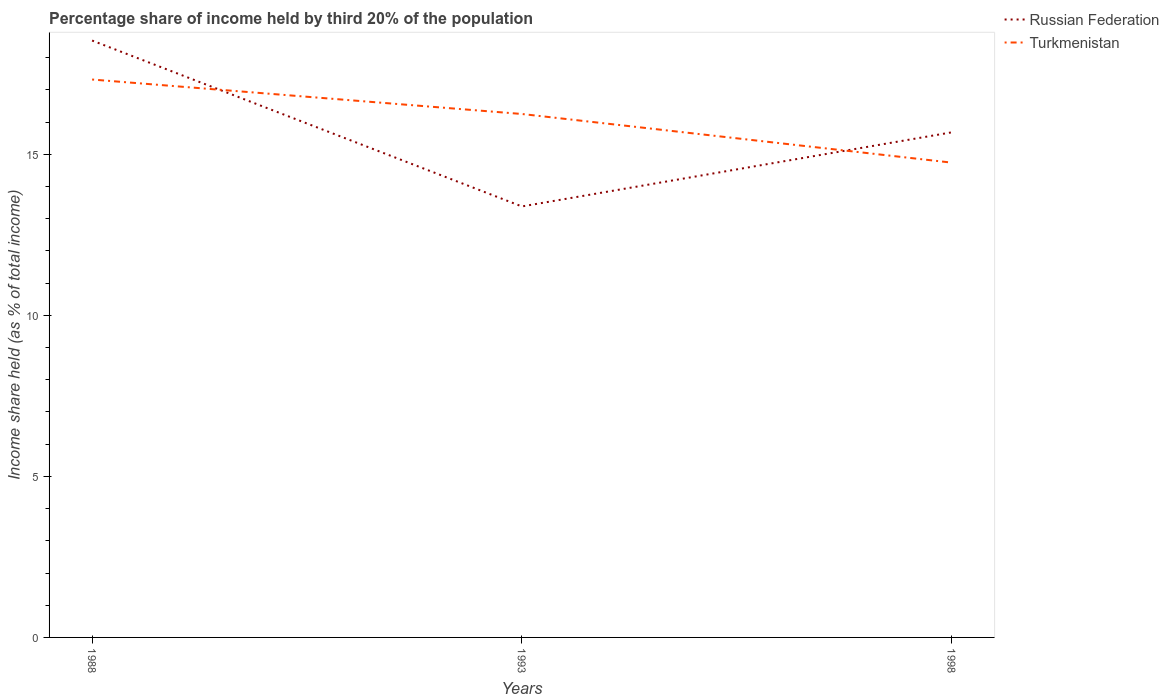How many different coloured lines are there?
Give a very brief answer. 2. Does the line corresponding to Russian Federation intersect with the line corresponding to Turkmenistan?
Give a very brief answer. Yes. Across all years, what is the maximum share of income held by third 20% of the population in Russian Federation?
Offer a very short reply. 13.38. In which year was the share of income held by third 20% of the population in Russian Federation maximum?
Offer a terse response. 1993. What is the total share of income held by third 20% of the population in Turkmenistan in the graph?
Your answer should be very brief. 1.51. What is the difference between the highest and the second highest share of income held by third 20% of the population in Turkmenistan?
Offer a very short reply. 2.58. How many lines are there?
Your response must be concise. 2. How many years are there in the graph?
Provide a succinct answer. 3. Are the values on the major ticks of Y-axis written in scientific E-notation?
Ensure brevity in your answer.  No. Does the graph contain any zero values?
Give a very brief answer. No. Does the graph contain grids?
Make the answer very short. No. Where does the legend appear in the graph?
Ensure brevity in your answer.  Top right. How many legend labels are there?
Make the answer very short. 2. How are the legend labels stacked?
Your answer should be compact. Vertical. What is the title of the graph?
Provide a succinct answer. Percentage share of income held by third 20% of the population. Does "Belarus" appear as one of the legend labels in the graph?
Give a very brief answer. No. What is the label or title of the Y-axis?
Your answer should be very brief. Income share held (as % of total income). What is the Income share held (as % of total income) of Russian Federation in 1988?
Give a very brief answer. 18.53. What is the Income share held (as % of total income) in Turkmenistan in 1988?
Provide a short and direct response. 17.32. What is the Income share held (as % of total income) of Russian Federation in 1993?
Offer a terse response. 13.38. What is the Income share held (as % of total income) in Turkmenistan in 1993?
Offer a very short reply. 16.25. What is the Income share held (as % of total income) in Russian Federation in 1998?
Your answer should be very brief. 15.68. What is the Income share held (as % of total income) in Turkmenistan in 1998?
Offer a terse response. 14.74. Across all years, what is the maximum Income share held (as % of total income) in Russian Federation?
Ensure brevity in your answer.  18.53. Across all years, what is the maximum Income share held (as % of total income) in Turkmenistan?
Give a very brief answer. 17.32. Across all years, what is the minimum Income share held (as % of total income) of Russian Federation?
Your answer should be very brief. 13.38. Across all years, what is the minimum Income share held (as % of total income) of Turkmenistan?
Your response must be concise. 14.74. What is the total Income share held (as % of total income) in Russian Federation in the graph?
Your answer should be very brief. 47.59. What is the total Income share held (as % of total income) of Turkmenistan in the graph?
Your answer should be very brief. 48.31. What is the difference between the Income share held (as % of total income) of Russian Federation in 1988 and that in 1993?
Ensure brevity in your answer.  5.15. What is the difference between the Income share held (as % of total income) of Turkmenistan in 1988 and that in 1993?
Offer a very short reply. 1.07. What is the difference between the Income share held (as % of total income) in Russian Federation in 1988 and that in 1998?
Provide a short and direct response. 2.85. What is the difference between the Income share held (as % of total income) in Turkmenistan in 1988 and that in 1998?
Offer a very short reply. 2.58. What is the difference between the Income share held (as % of total income) in Russian Federation in 1993 and that in 1998?
Keep it short and to the point. -2.3. What is the difference between the Income share held (as % of total income) in Turkmenistan in 1993 and that in 1998?
Ensure brevity in your answer.  1.51. What is the difference between the Income share held (as % of total income) of Russian Federation in 1988 and the Income share held (as % of total income) of Turkmenistan in 1993?
Your response must be concise. 2.28. What is the difference between the Income share held (as % of total income) in Russian Federation in 1988 and the Income share held (as % of total income) in Turkmenistan in 1998?
Your response must be concise. 3.79. What is the difference between the Income share held (as % of total income) in Russian Federation in 1993 and the Income share held (as % of total income) in Turkmenistan in 1998?
Provide a succinct answer. -1.36. What is the average Income share held (as % of total income) of Russian Federation per year?
Keep it short and to the point. 15.86. What is the average Income share held (as % of total income) in Turkmenistan per year?
Give a very brief answer. 16.1. In the year 1988, what is the difference between the Income share held (as % of total income) of Russian Federation and Income share held (as % of total income) of Turkmenistan?
Provide a short and direct response. 1.21. In the year 1993, what is the difference between the Income share held (as % of total income) in Russian Federation and Income share held (as % of total income) in Turkmenistan?
Give a very brief answer. -2.87. What is the ratio of the Income share held (as % of total income) in Russian Federation in 1988 to that in 1993?
Offer a very short reply. 1.38. What is the ratio of the Income share held (as % of total income) in Turkmenistan in 1988 to that in 1993?
Your answer should be compact. 1.07. What is the ratio of the Income share held (as % of total income) in Russian Federation in 1988 to that in 1998?
Offer a very short reply. 1.18. What is the ratio of the Income share held (as % of total income) of Turkmenistan in 1988 to that in 1998?
Make the answer very short. 1.18. What is the ratio of the Income share held (as % of total income) of Russian Federation in 1993 to that in 1998?
Offer a very short reply. 0.85. What is the ratio of the Income share held (as % of total income) in Turkmenistan in 1993 to that in 1998?
Provide a succinct answer. 1.1. What is the difference between the highest and the second highest Income share held (as % of total income) of Russian Federation?
Offer a terse response. 2.85. What is the difference between the highest and the second highest Income share held (as % of total income) in Turkmenistan?
Offer a terse response. 1.07. What is the difference between the highest and the lowest Income share held (as % of total income) of Russian Federation?
Your answer should be very brief. 5.15. What is the difference between the highest and the lowest Income share held (as % of total income) of Turkmenistan?
Provide a succinct answer. 2.58. 